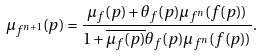<formula> <loc_0><loc_0><loc_500><loc_500>\mu _ { f ^ { n + 1 } } ( p ) = \frac { \mu _ { f } ( p ) + \theta _ { f } ( p ) \mu _ { f ^ { n } } ( f ( p ) ) } { 1 + \overline { \mu _ { f } ( p ) } \theta _ { f } ( p ) \mu _ { f ^ { n } } ( f ( p ) ) } .</formula> 